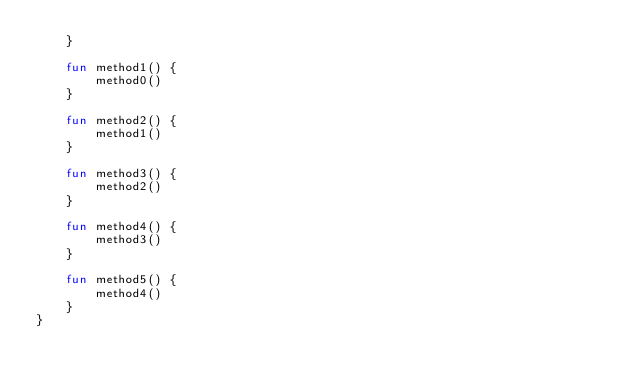<code> <loc_0><loc_0><loc_500><loc_500><_Kotlin_>    }

    fun method1() {
        method0()
    }

    fun method2() {
        method1()
    }

    fun method3() {
        method2()
    }

    fun method4() {
        method3()
    }

    fun method5() {
        method4()
    }
}
</code> 